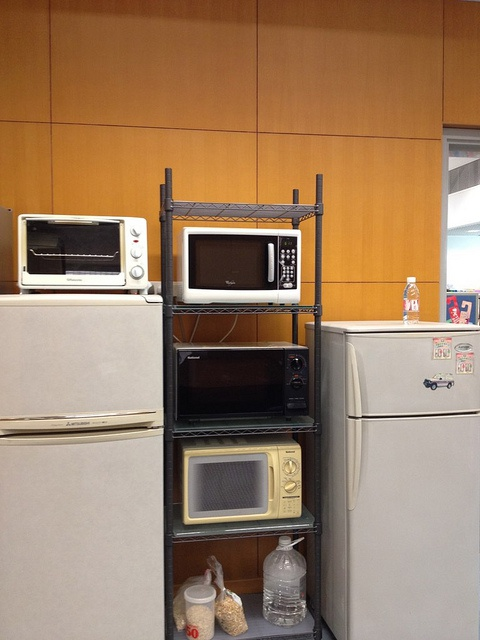Describe the objects in this image and their specific colors. I can see refrigerator in maroon, darkgray, and lightgray tones, refrigerator in maroon, darkgray, gray, and lightgray tones, oven in maroon, black, ivory, tan, and darkgray tones, microwave in maroon, black, ivory, tan, and darkgray tones, and microwave in maroon, black, and gray tones in this image. 